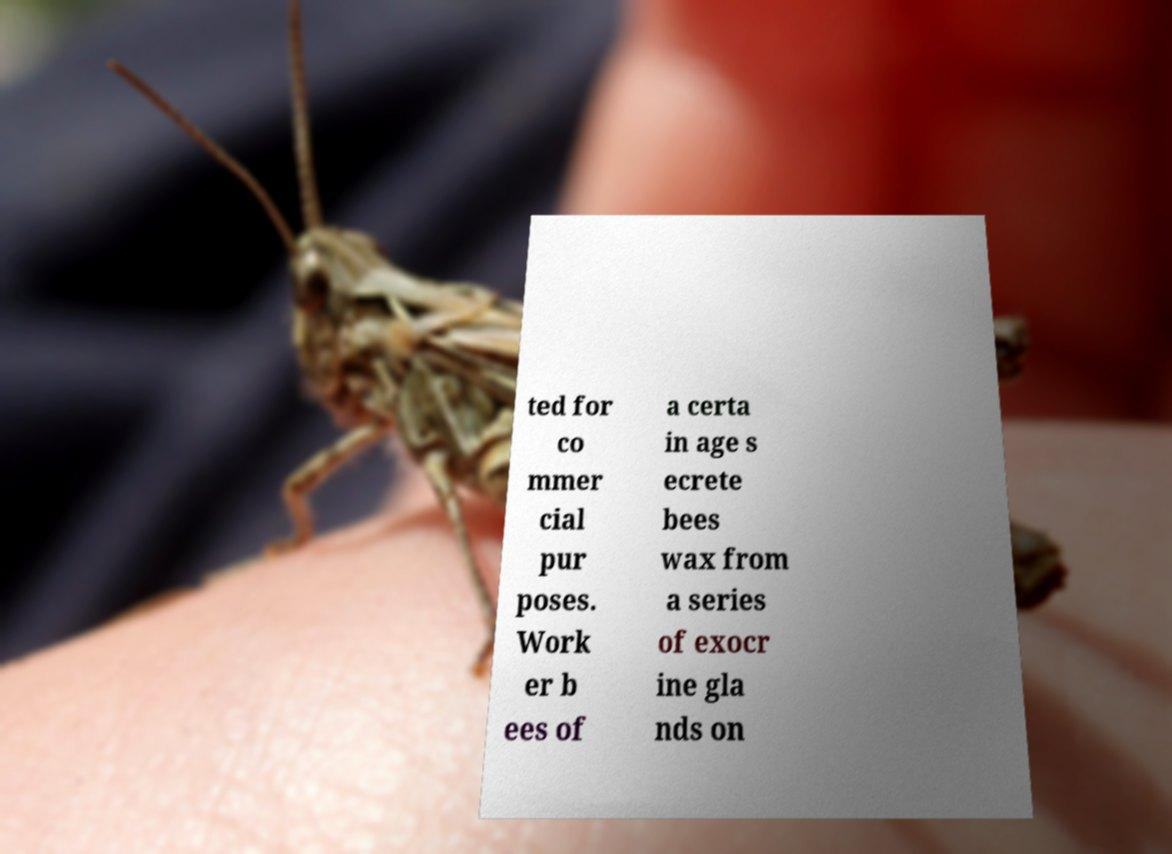Can you read and provide the text displayed in the image?This photo seems to have some interesting text. Can you extract and type it out for me? ted for co mmer cial pur poses. Work er b ees of a certa in age s ecrete bees wax from a series of exocr ine gla nds on 